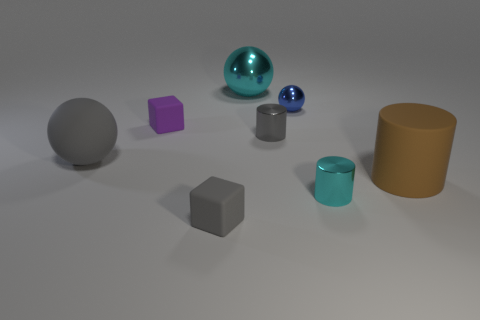Subtract all big brown matte cylinders. How many cylinders are left? 2 Subtract 1 balls. How many balls are left? 2 Add 1 purple objects. How many objects exist? 9 Subtract all green cylinders. Subtract all cyan cubes. How many cylinders are left? 3 Add 4 tiny yellow metallic blocks. How many tiny yellow metallic blocks exist? 4 Subtract 1 purple cubes. How many objects are left? 7 Subtract all blocks. How many objects are left? 6 Subtract all small shiny things. Subtract all small cylinders. How many objects are left? 3 Add 7 brown cylinders. How many brown cylinders are left? 8 